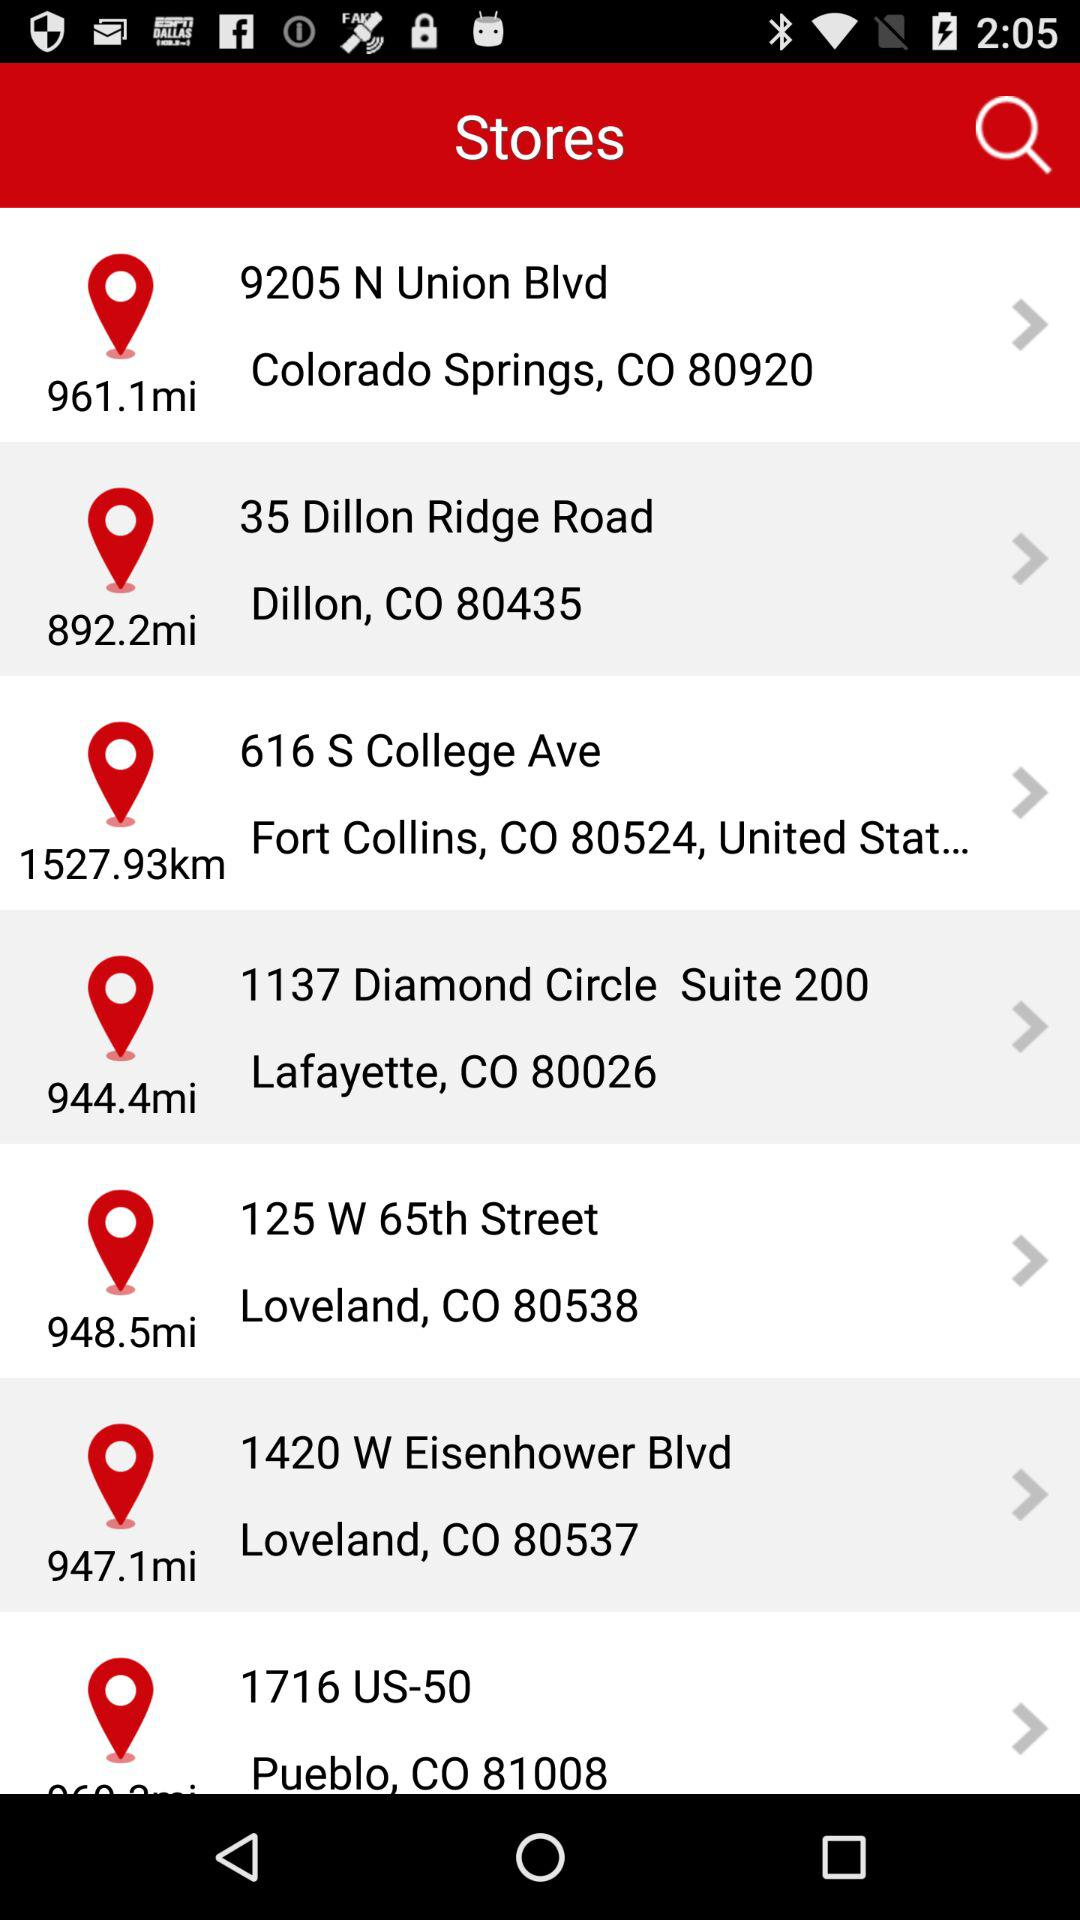How far is the store at 35 Dillon Ridge Road, Dillon, CO 80435 away? The store at 35 Dillon Ridge Road, Dillon, CO 80435 is 892.2 miles away. 